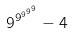<formula> <loc_0><loc_0><loc_500><loc_500>9 ^ { 9 ^ { 9 ^ { 9 ^ { 9 } } } } - 4</formula> 